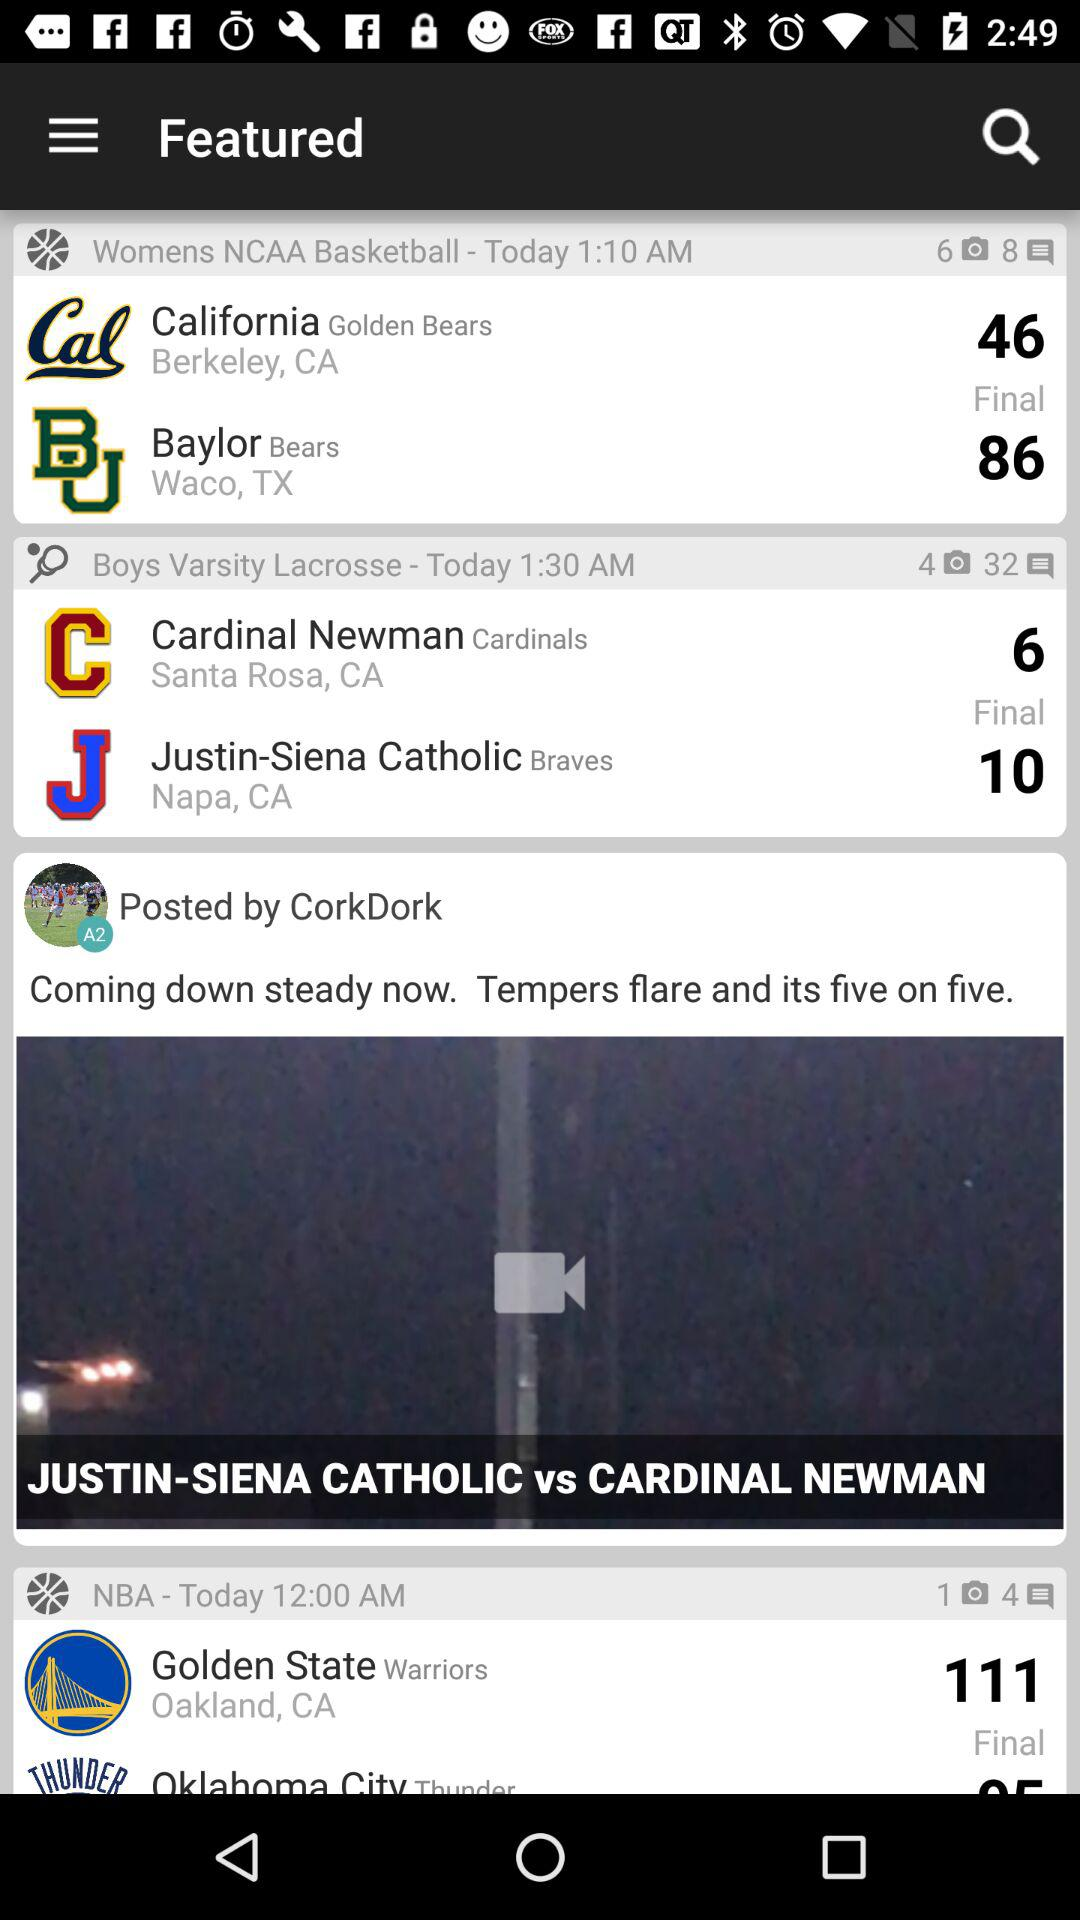How many games are in progress?
Answer the question using a single word or phrase. 3 